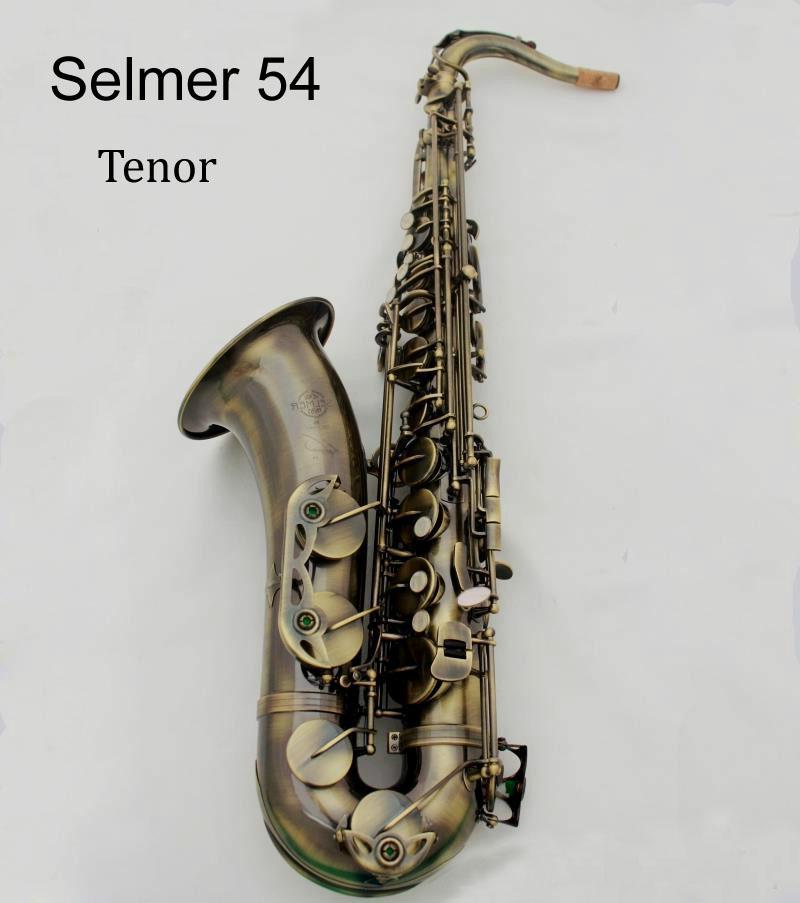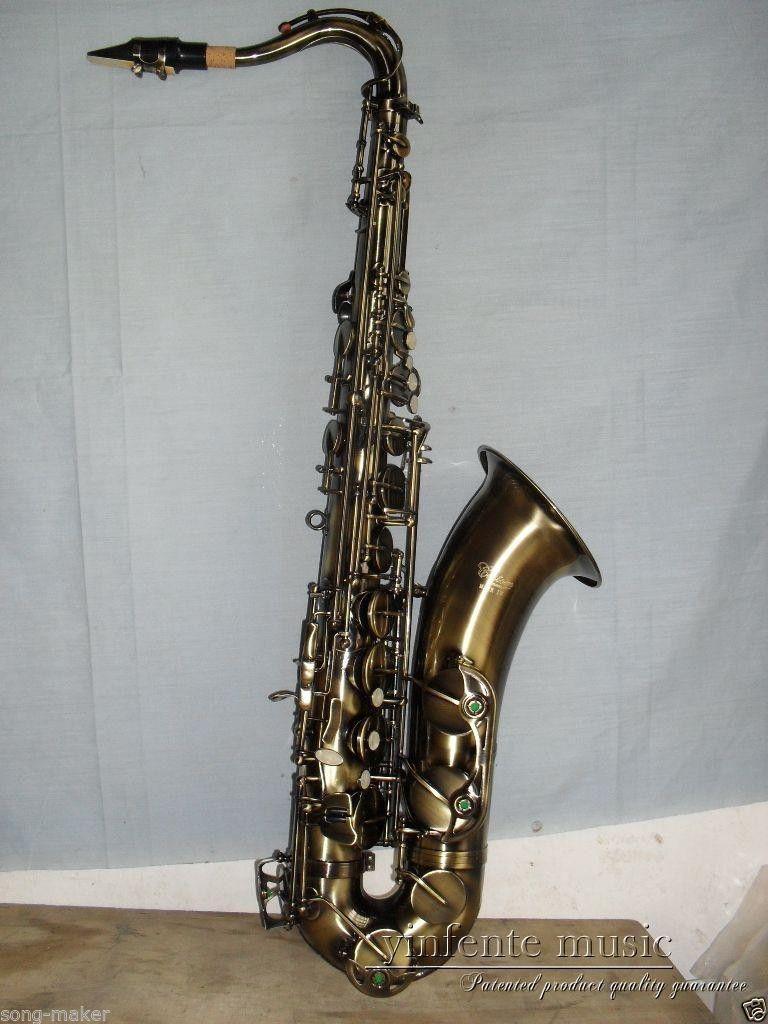The first image is the image on the left, the second image is the image on the right. Assess this claim about the two images: "At least one saxophone is not a traditional metal color.". Correct or not? Answer yes or no. No. The first image is the image on the left, the second image is the image on the right. Evaluate the accuracy of this statement regarding the images: "Both of the saxophones are set up in the same position.". Is it true? Answer yes or no. No. 